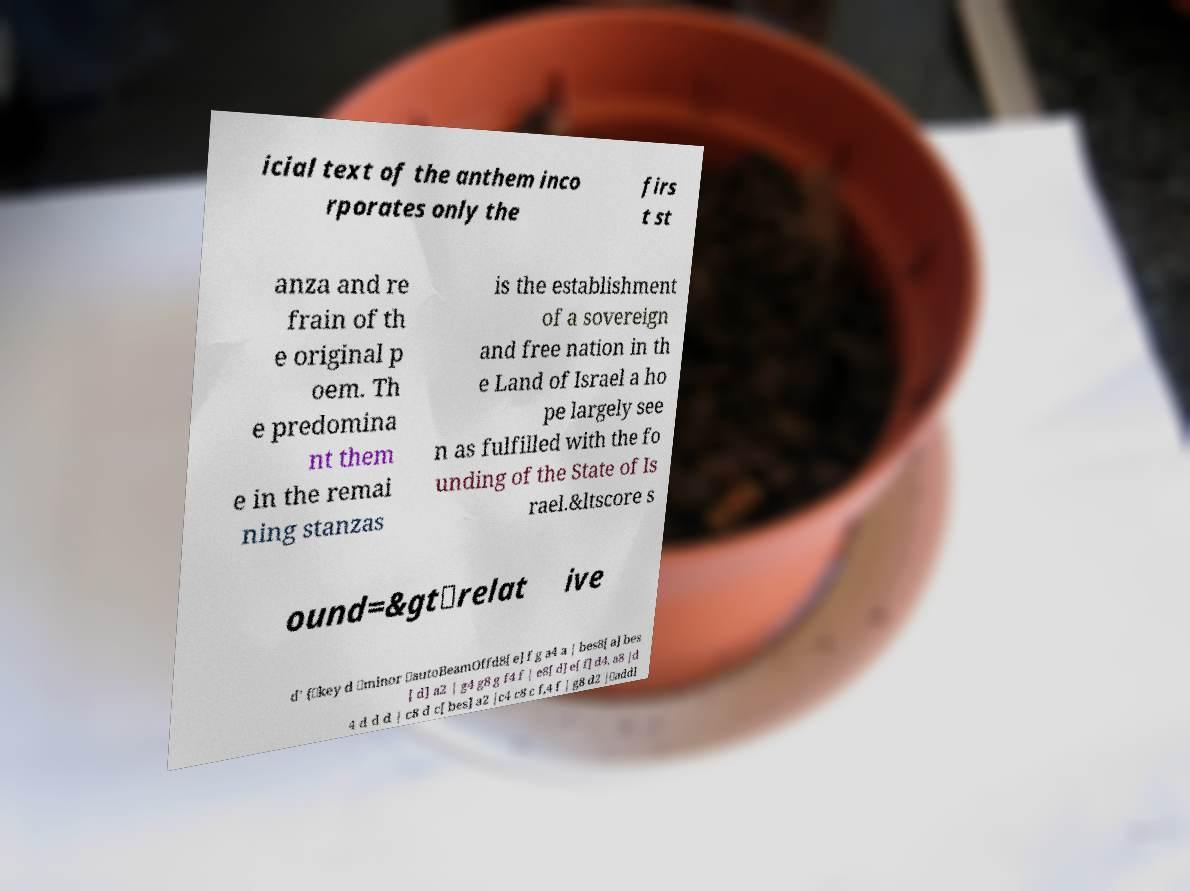I need the written content from this picture converted into text. Can you do that? icial text of the anthem inco rporates only the firs t st anza and re frain of th e original p oem. Th e predomina nt them e in the remai ning stanzas is the establishment of a sovereign and free nation in th e Land of Israel a ho pe largely see n as fulfilled with the fo unding of the State of Is rael.&ltscore s ound=&gt\relat ive d' {\key d \minor \autoBeamOffd8[ e] f g a4 a | bes8[ a] bes [ d] a2 | g4 g8 g f4 f | e8[ d] e[ f] d4. a8 |d 4 d d d | c8 d c[ bes] a2 |c4 c8 c f,4 f | g8 d2 |\addl 